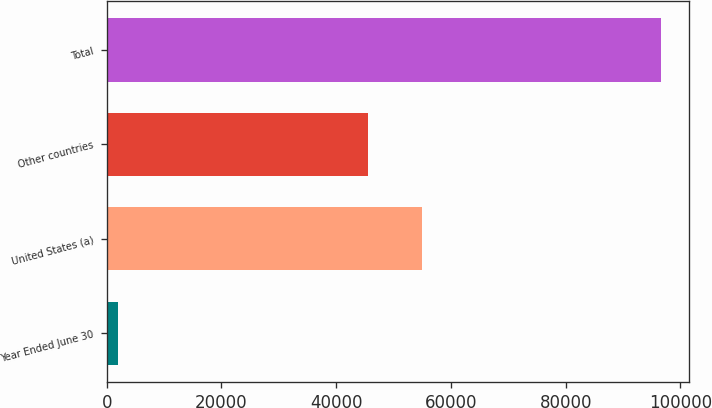Convert chart to OTSL. <chart><loc_0><loc_0><loc_500><loc_500><bar_chart><fcel>Year Ended June 30<fcel>United States (a)<fcel>Other countries<fcel>Total<nl><fcel>2017<fcel>54948.4<fcel>45493<fcel>96571<nl></chart> 